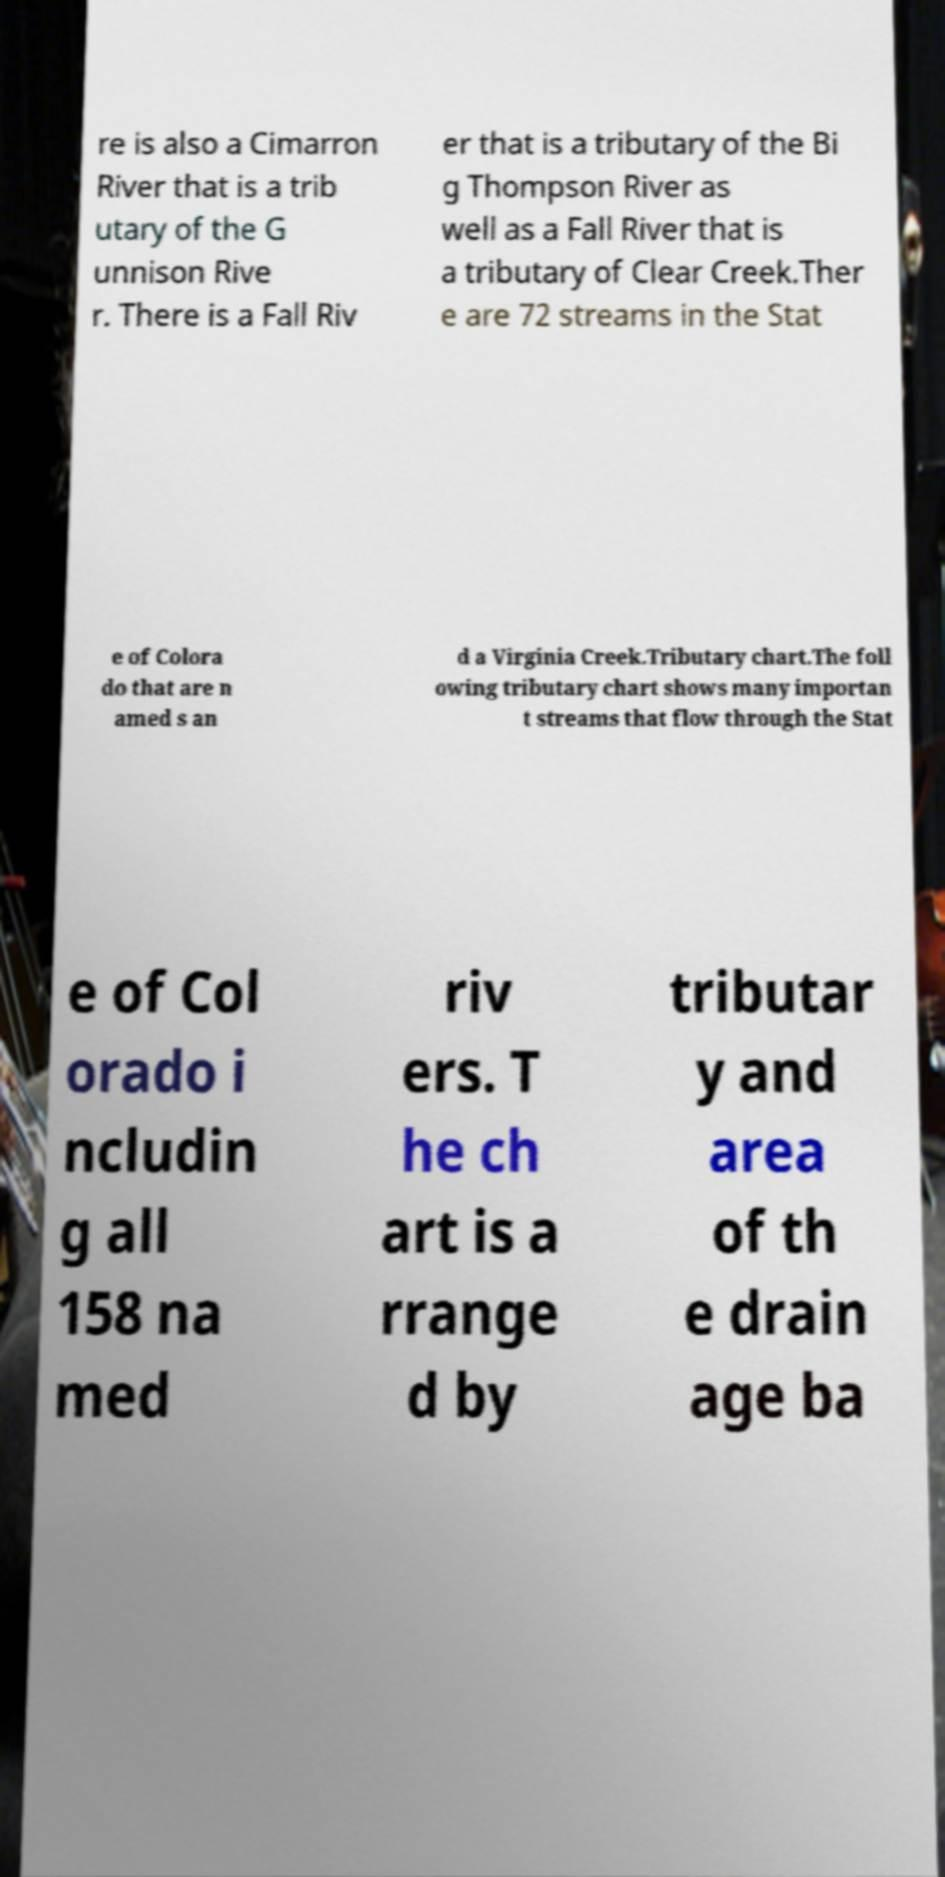What messages or text are displayed in this image? I need them in a readable, typed format. re is also a Cimarron River that is a trib utary of the G unnison Rive r. There is a Fall Riv er that is a tributary of the Bi g Thompson River as well as a Fall River that is a tributary of Clear Creek.Ther e are 72 streams in the Stat e of Colora do that are n amed s an d a Virginia Creek.Tributary chart.The foll owing tributary chart shows many importan t streams that flow through the Stat e of Col orado i ncludin g all 158 na med riv ers. T he ch art is a rrange d by tributar y and area of th e drain age ba 